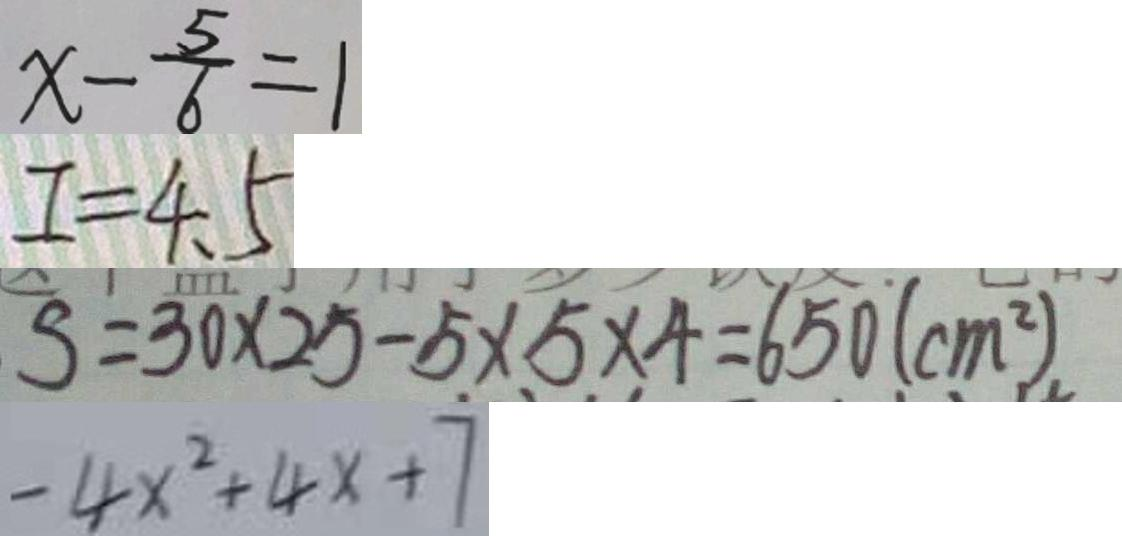<formula> <loc_0><loc_0><loc_500><loc_500>x - \frac { 5 } { 6 } = 1 
 I = 4 . 5 
 S = 3 0 \times 2 5 - 5 \times 5 \times 4 = 6 5 0 ( c m ) ^ { 2 } 
 - 4 x ^ { 2 } + 4 x + 7</formula> 